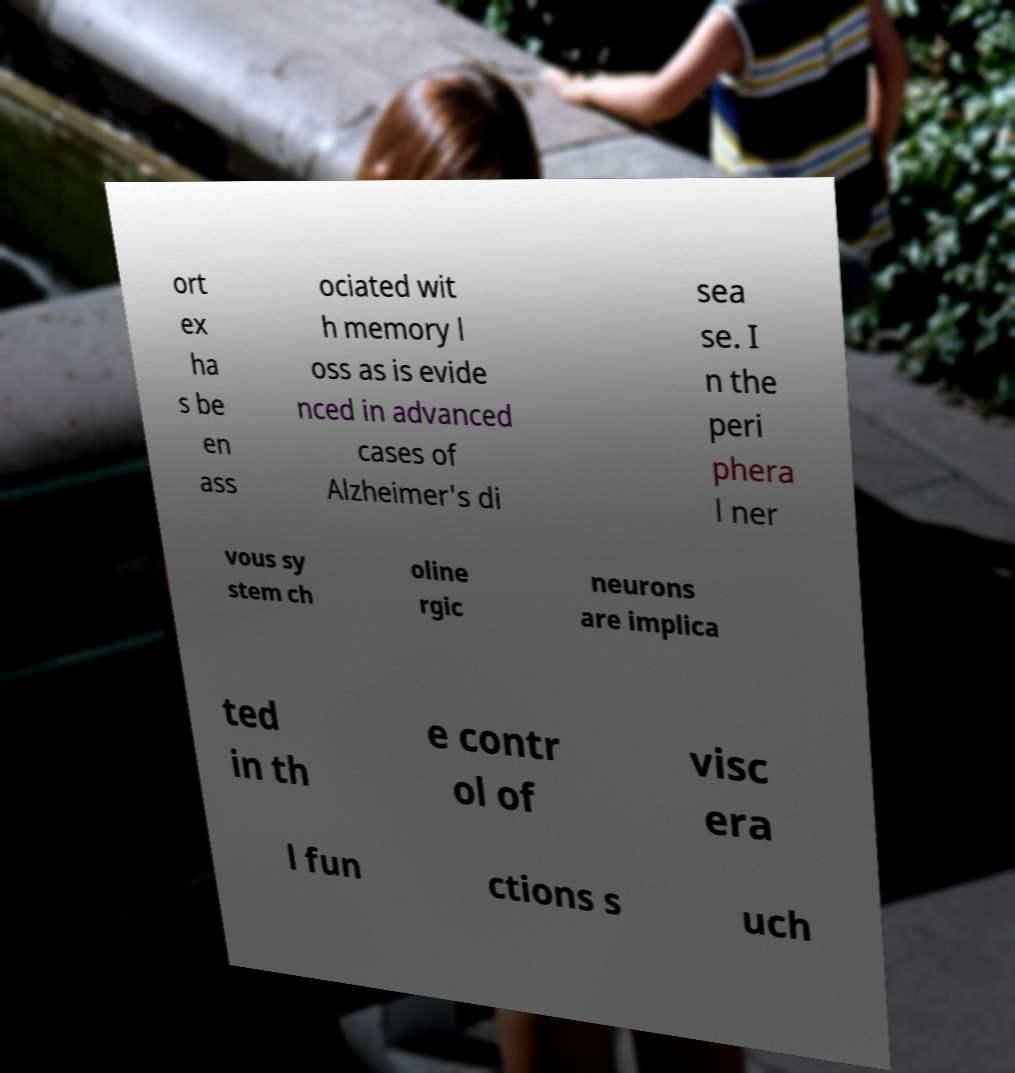Can you read and provide the text displayed in the image?This photo seems to have some interesting text. Can you extract and type it out for me? ort ex ha s be en ass ociated wit h memory l oss as is evide nced in advanced cases of Alzheimer's di sea se. I n the peri phera l ner vous sy stem ch oline rgic neurons are implica ted in th e contr ol of visc era l fun ctions s uch 